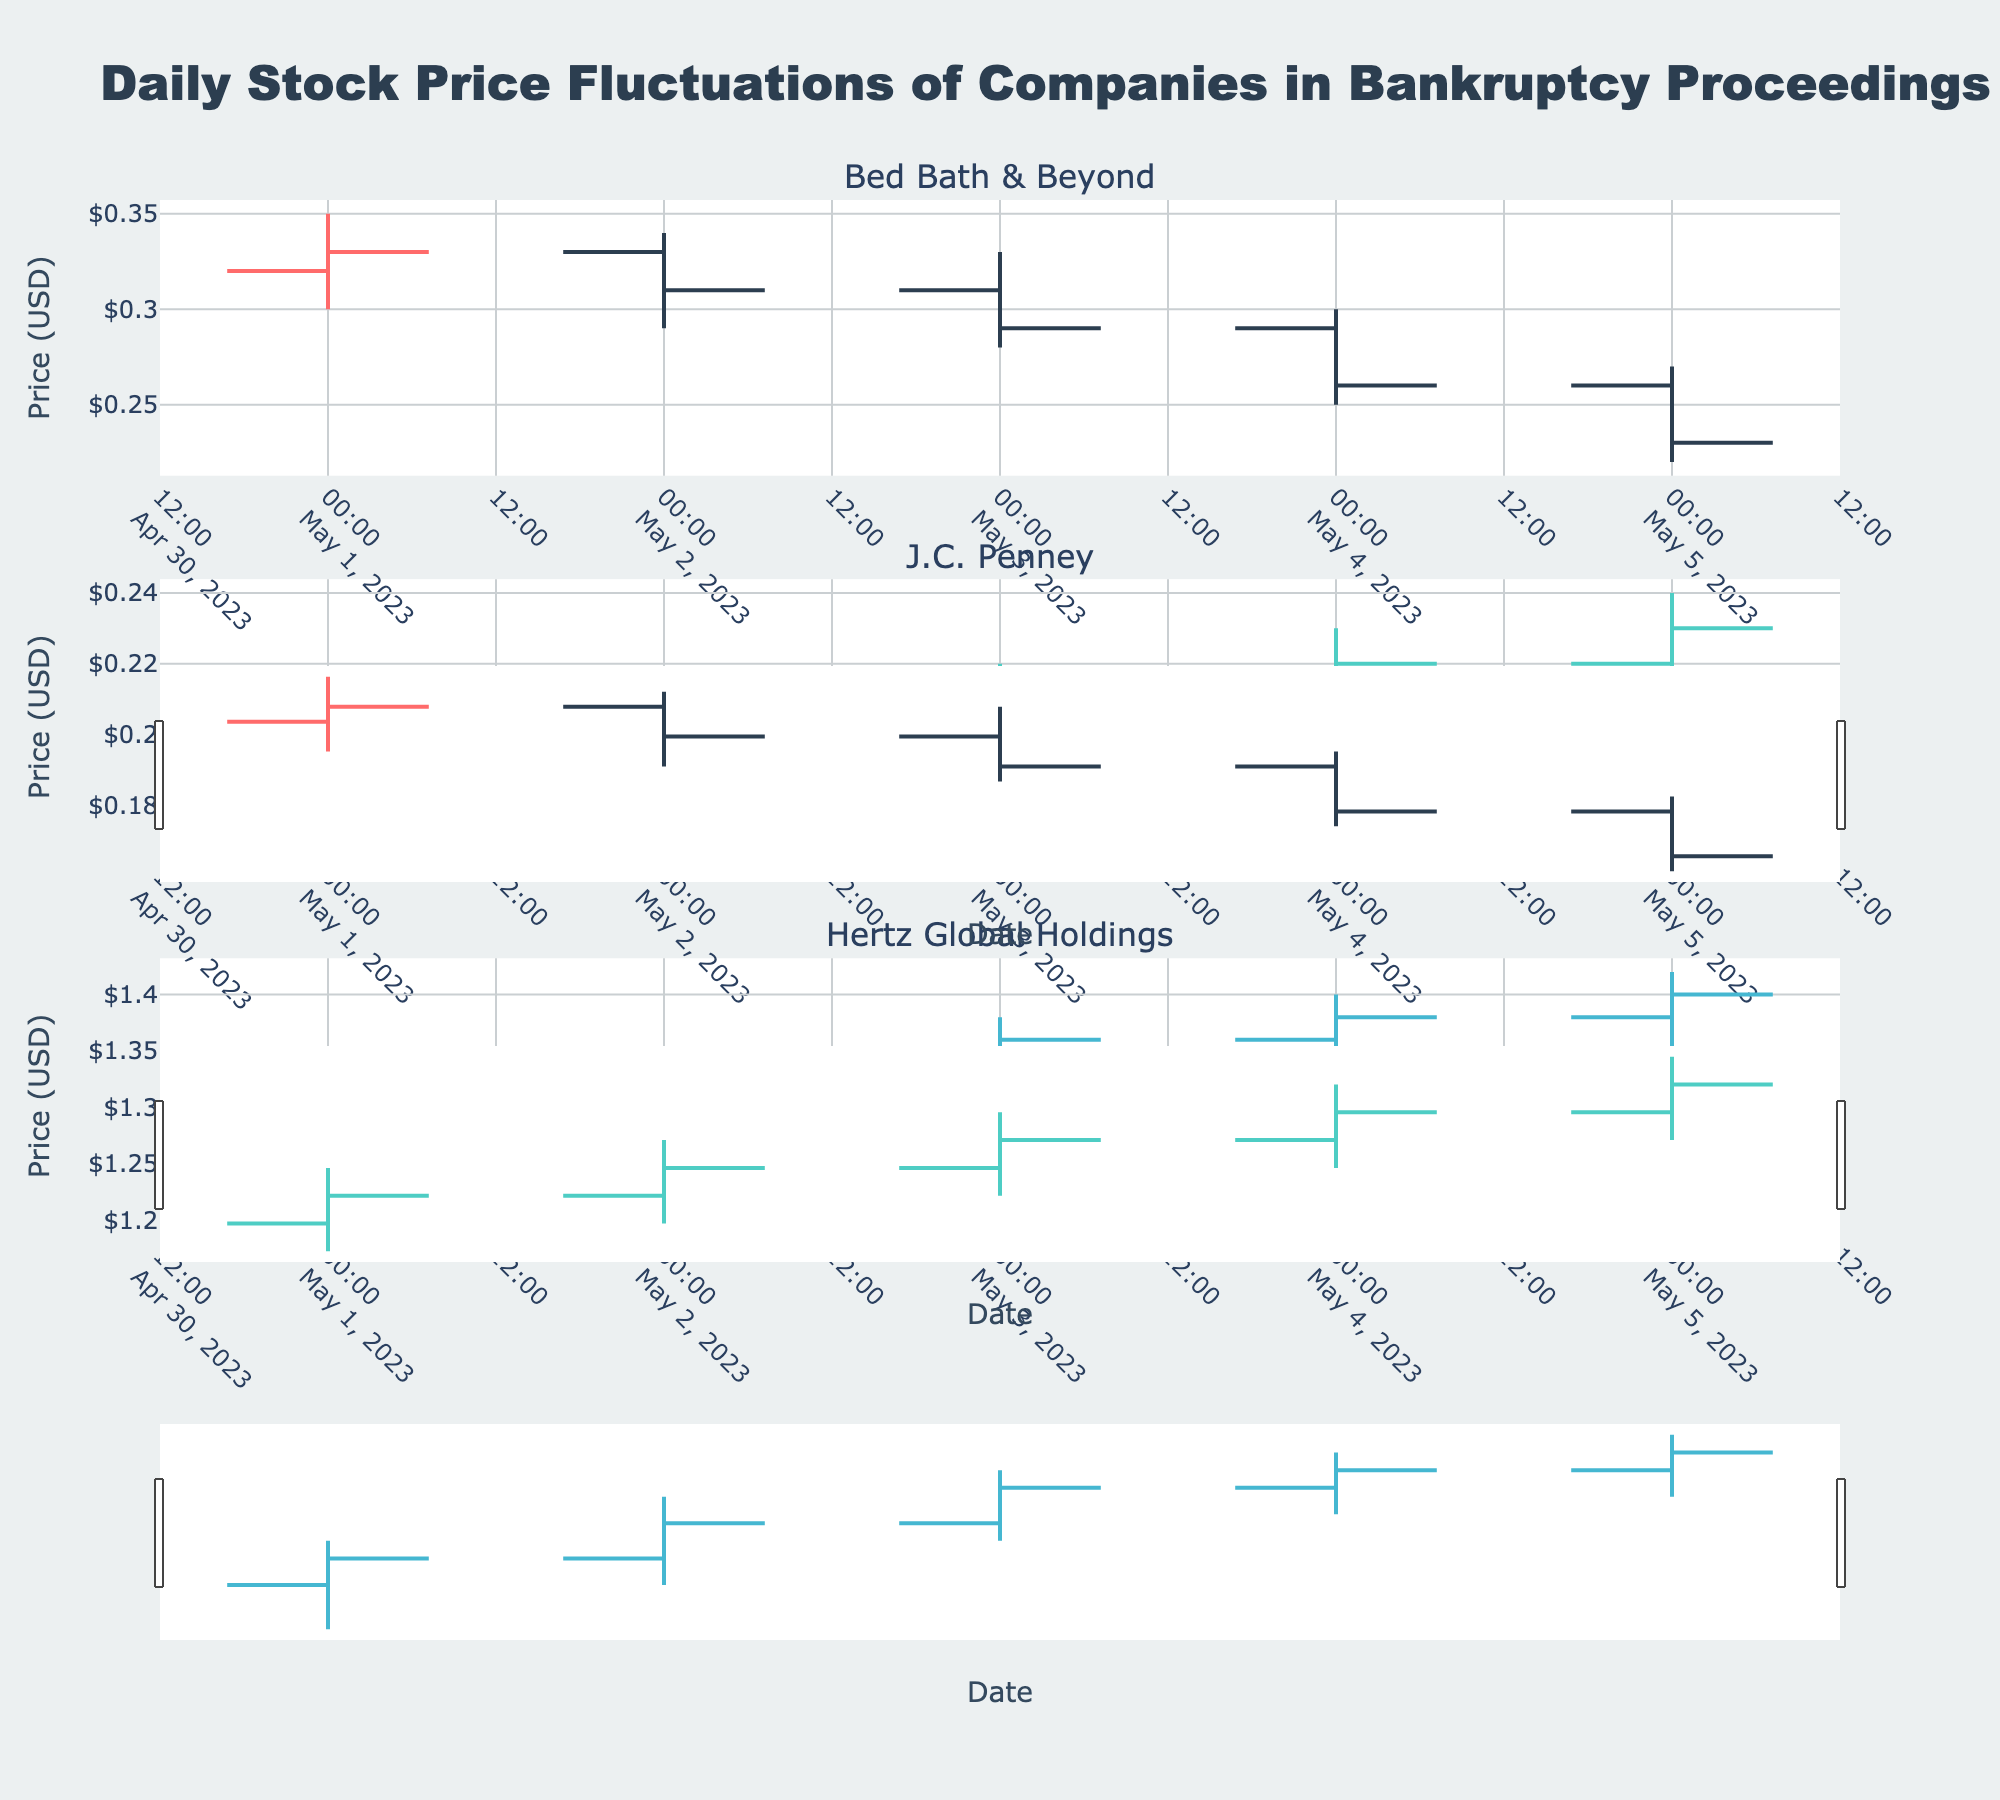Which company has the highest closing price on May 5? The closing prices on May 5 are: Bed Bath & Beyond ($0.23), J.C. Penney ($0.23), and Hertz Global Holdings ($1.40). Hertz Global Holdings has the highest closing price.
Answer: Hertz Global Holdings Which company experienced the largest drop in closing price between May 1 and May 5? Calculate the difference between the closing prices on May 1 and May 5 for each company: Bed Bath & Beyond ($0.33 - $0.23 = $0.10), J.C. Penney ($0.19 - $0.23 = -$0.04), and Hertz Global Holdings ($1.28 - $1.40 = -$0.12). Bed Bath & Beyond experienced the largest drop.
Answer: Bed Bath & Beyond What is the average closing price for J.C. Penney over the 5-day period? Sum the closing prices over the 5 days: $0.19 + $0.20 + $0.21 + $0.22 + $0.23 = $1.05. Divide by the number of days (5): $1.05 / 5 = $0.21
Answer: $0.21 Which company had an increasing trend in closing prices for the majority of the days from May 1 to May 5? Observe the trends in closing prices for each company: Bed Bath & Beyond has a decreasing trend, J.C. Penney has an increasing trend, Hertz Global Holdings has an increasing trend. Both J.C. Penney and Hertz Global Holdings have increasing trends for the majority of the days.
Answer: J.C. Penney, Hertz Global Holdings What was the low price for Hertz Global Holdings on May 4? Refer to the low price value for Hertz Global Holdings on May 4, which is $1.33
Answer: $1.33 How many companies had a closing price lower than their opening price on May 3? Compare the opening and closing prices for each company on May 3: Bed Bath & Beyond (Open $0.31, Close $0.29), J.C. Penney (Open $0.20, Close $0.21), Hertz Global Holdings (Open $1.32, Close $1.36). Only Bed Bath & Beyond had a closing price lower than its opening price.
Answer: 1 Which company exhibited the most stable closing price over the 5-day period? Calculate the variance in closing prices for each company, lower variance indicates more stability: Bed Bath & Beyond = 0.01 (High), J.C. Penney = 0.001 (Stable), Hertz Global Holdings = 0.007 (Moderate). J.C. Penney exhibited the most stable closing price.
Answer: J.C. Penney What's the highest price recorded by any company during the 5-day period? Look at the highest prices in the dataset: Bed Bath & Beyond ($0.35), J.C. Penney ($0.24), Hertz Global Holdings ($1.42). The highest is Hertz Global Holdings at $1.42.
Answer: $1.42 Which company had the lowest low price on May 5? Check the low prices of all companies on May 5: Bed Bath & Beyond ($0.22), J.C. Penney ($0.21), Hertz Global Holdings ($1.35). J.C. Penney had the lowest low price.
Answer: J.C. Penney On which date did Bed Bath & Beyond have the lowest closing price? Compare the closing prices for Bed Bath & Beyond on each date: May 1 ($0.33), May 2 ($0.31), May 3 ($0.29), May 4 ($0.26), May 5 ($0.23). The lowest closing price was on May 5.
Answer: May 5 